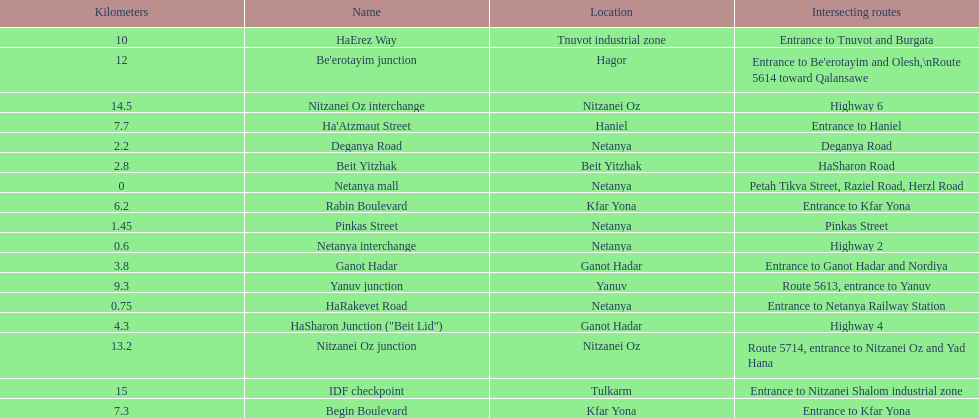Which section is longest?? IDF checkpoint. 